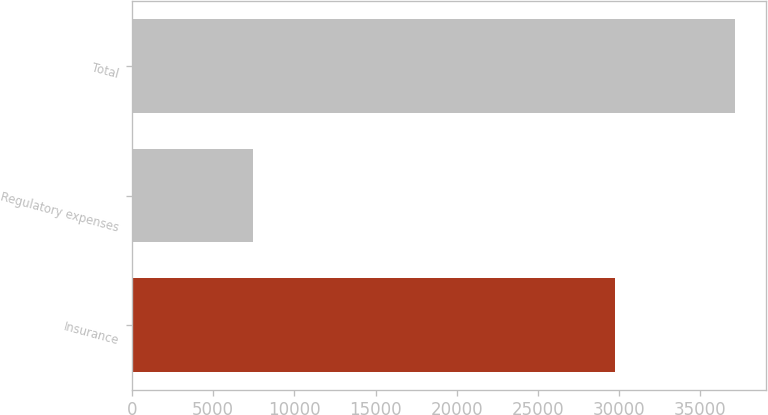Convert chart to OTSL. <chart><loc_0><loc_0><loc_500><loc_500><bar_chart><fcel>Insurance<fcel>Regulatory expenses<fcel>Total<nl><fcel>29733<fcel>7433<fcel>37166<nl></chart> 